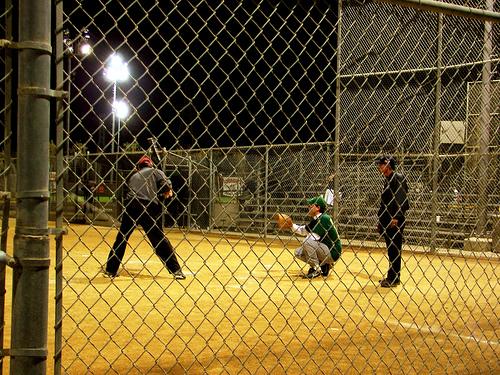Was this taken during daylight?
Answer briefly. No. Is this a day game?
Give a very brief answer. No. Is this a practice session?
Concise answer only. Yes. Are the men on the same team?
Short answer required. No. What are the roles of the three men in this picture?
Quick response, please. Batter, catcher, umpire. 